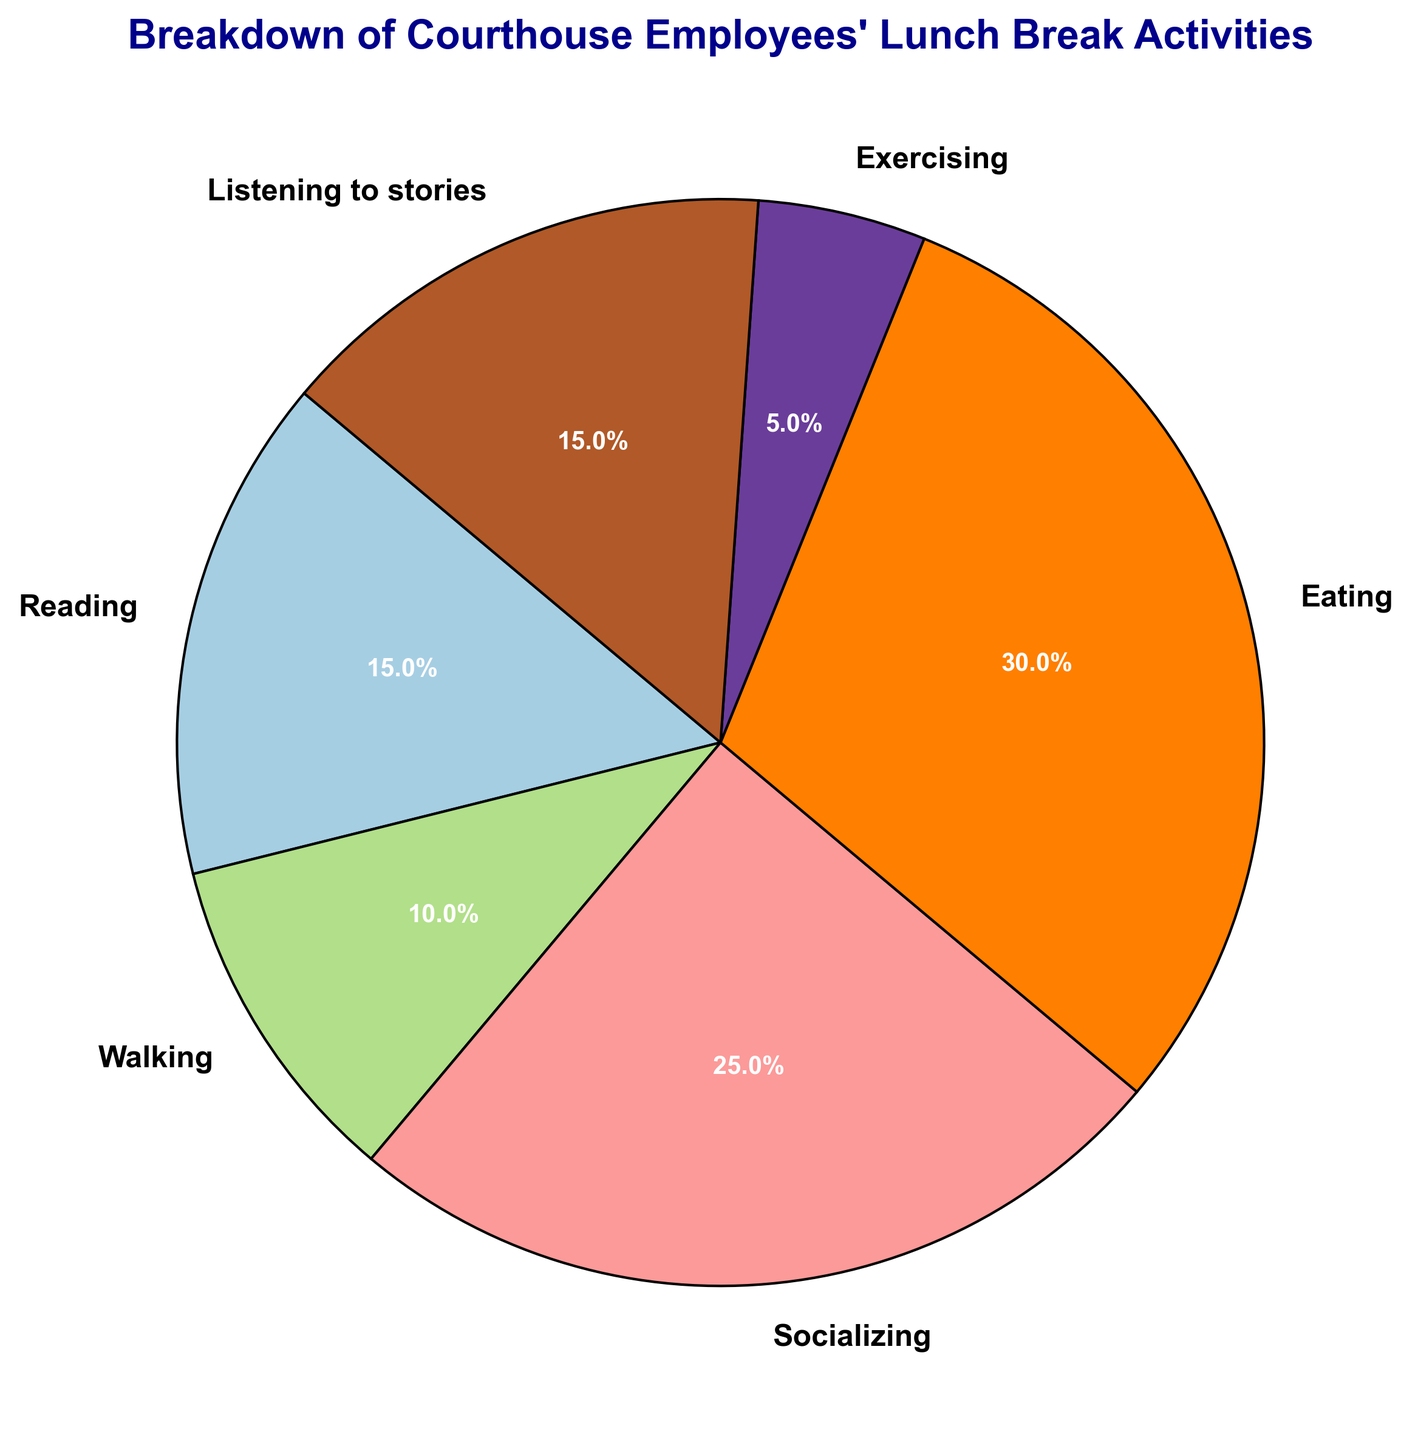What activity do courthouse employees engage in the most during their lunch break? The category with the largest percentage represents the activity engaged in the most. According to the pie chart, "Eating" accounts for the largest portion.
Answer: Eating What is the combined percentage for Reading and Listening to stories? To find the combined percentage, sum the percentages of the two activities. Reading is 15% and Listening to stories is also 15%, so 15% + 15% = 30%.
Answer: 30% Which activity is engaged in the least during lunch breaks? The activity with the smallest wedge in the pie chart represents the least engaged activity. "Exercising" holds the smallest percentage at 5%.
Answer: Exercising How much greater is the percentage of Socializing compared to Exercising? To find the difference, subtract the percentage of Exercising from Socializing. Socializing is 25% and Exercising is 5%, so 25% - 5% = 20%.
Answer: 20% What is the average percentage of the activities Reading, Walking, and Exercising? To find the average, sum the percentages of these activities and divide by the number of activities. Reading is 15%, Walking is 10%, and Exercising is 5%. (15% + 10% + 5%) / 3 = 30% / 3 = 10%.
Answer: 10% Which two activities together make up 40% of the employees' lunch break activities? Compare combinations of percentages to find a pair that adds up to 40%. Reading (15%) and Listening to stories (15%) together make 30%, not 40%. Socializing (25%) and Walking (10%) together make 35%, not 40%. Socializing (25%) and Listening to stories (15%) together make 40%.
Answer: Socializing and Listening to stories Is the percentage of employees who eat during lunch breaks greater, less than, or equal to the combined percentage of those who read and listen to stories? Compare the percentage of Eating (30%) to the sum of Reading (15%) and Listening to stories (15%), which is 30%. Since 30% = 30%, they are equal.
Answer: Equal 